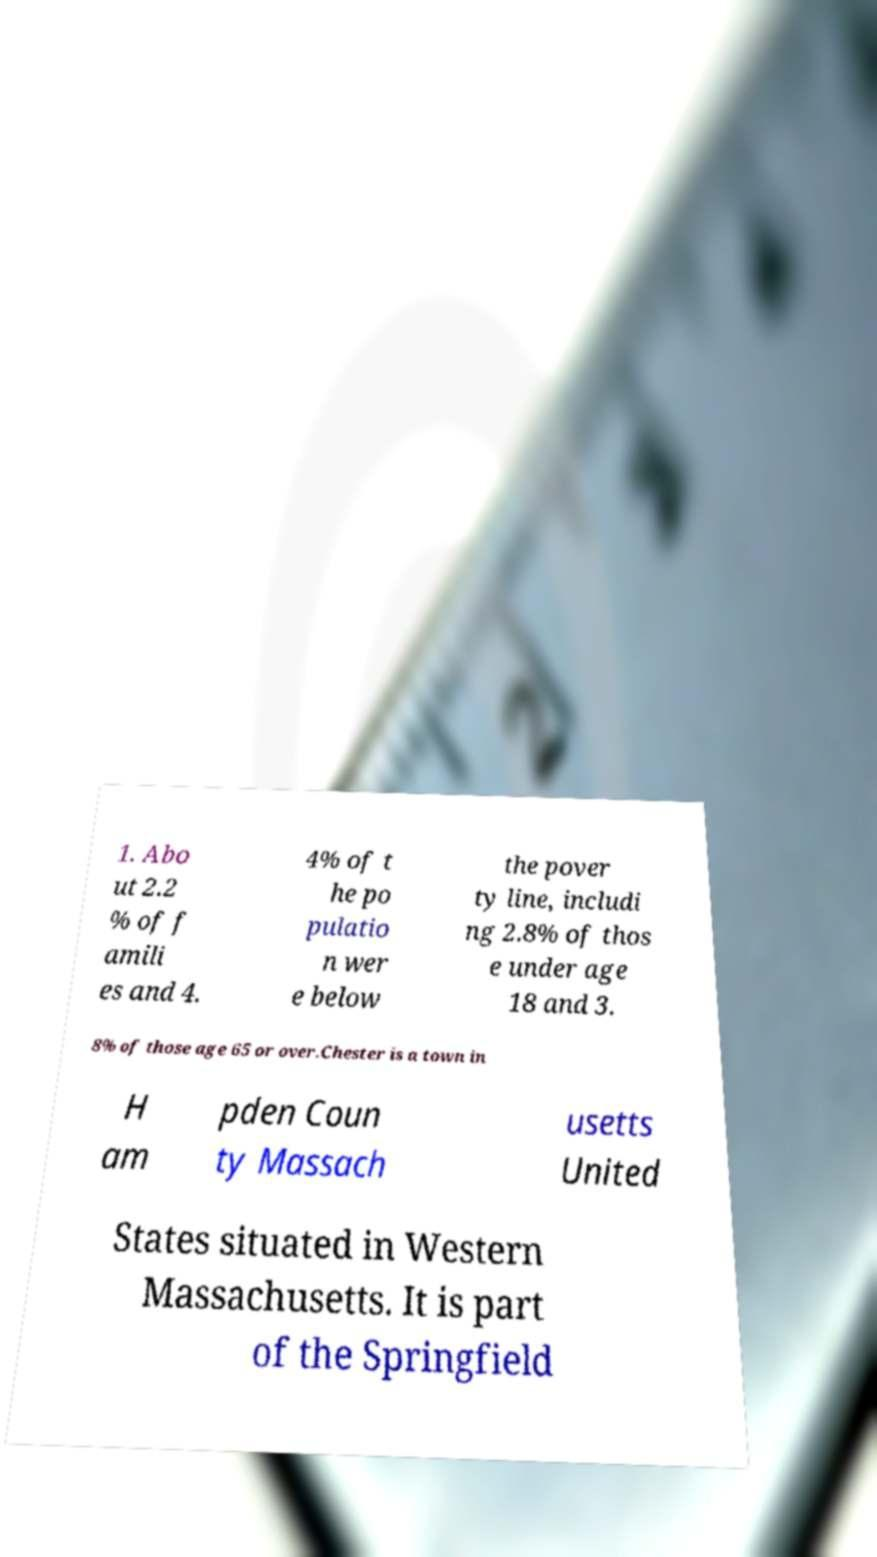What messages or text are displayed in this image? I need them in a readable, typed format. 1. Abo ut 2.2 % of f amili es and 4. 4% of t he po pulatio n wer e below the pover ty line, includi ng 2.8% of thos e under age 18 and 3. 8% of those age 65 or over.Chester is a town in H am pden Coun ty Massach usetts United States situated in Western Massachusetts. It is part of the Springfield 